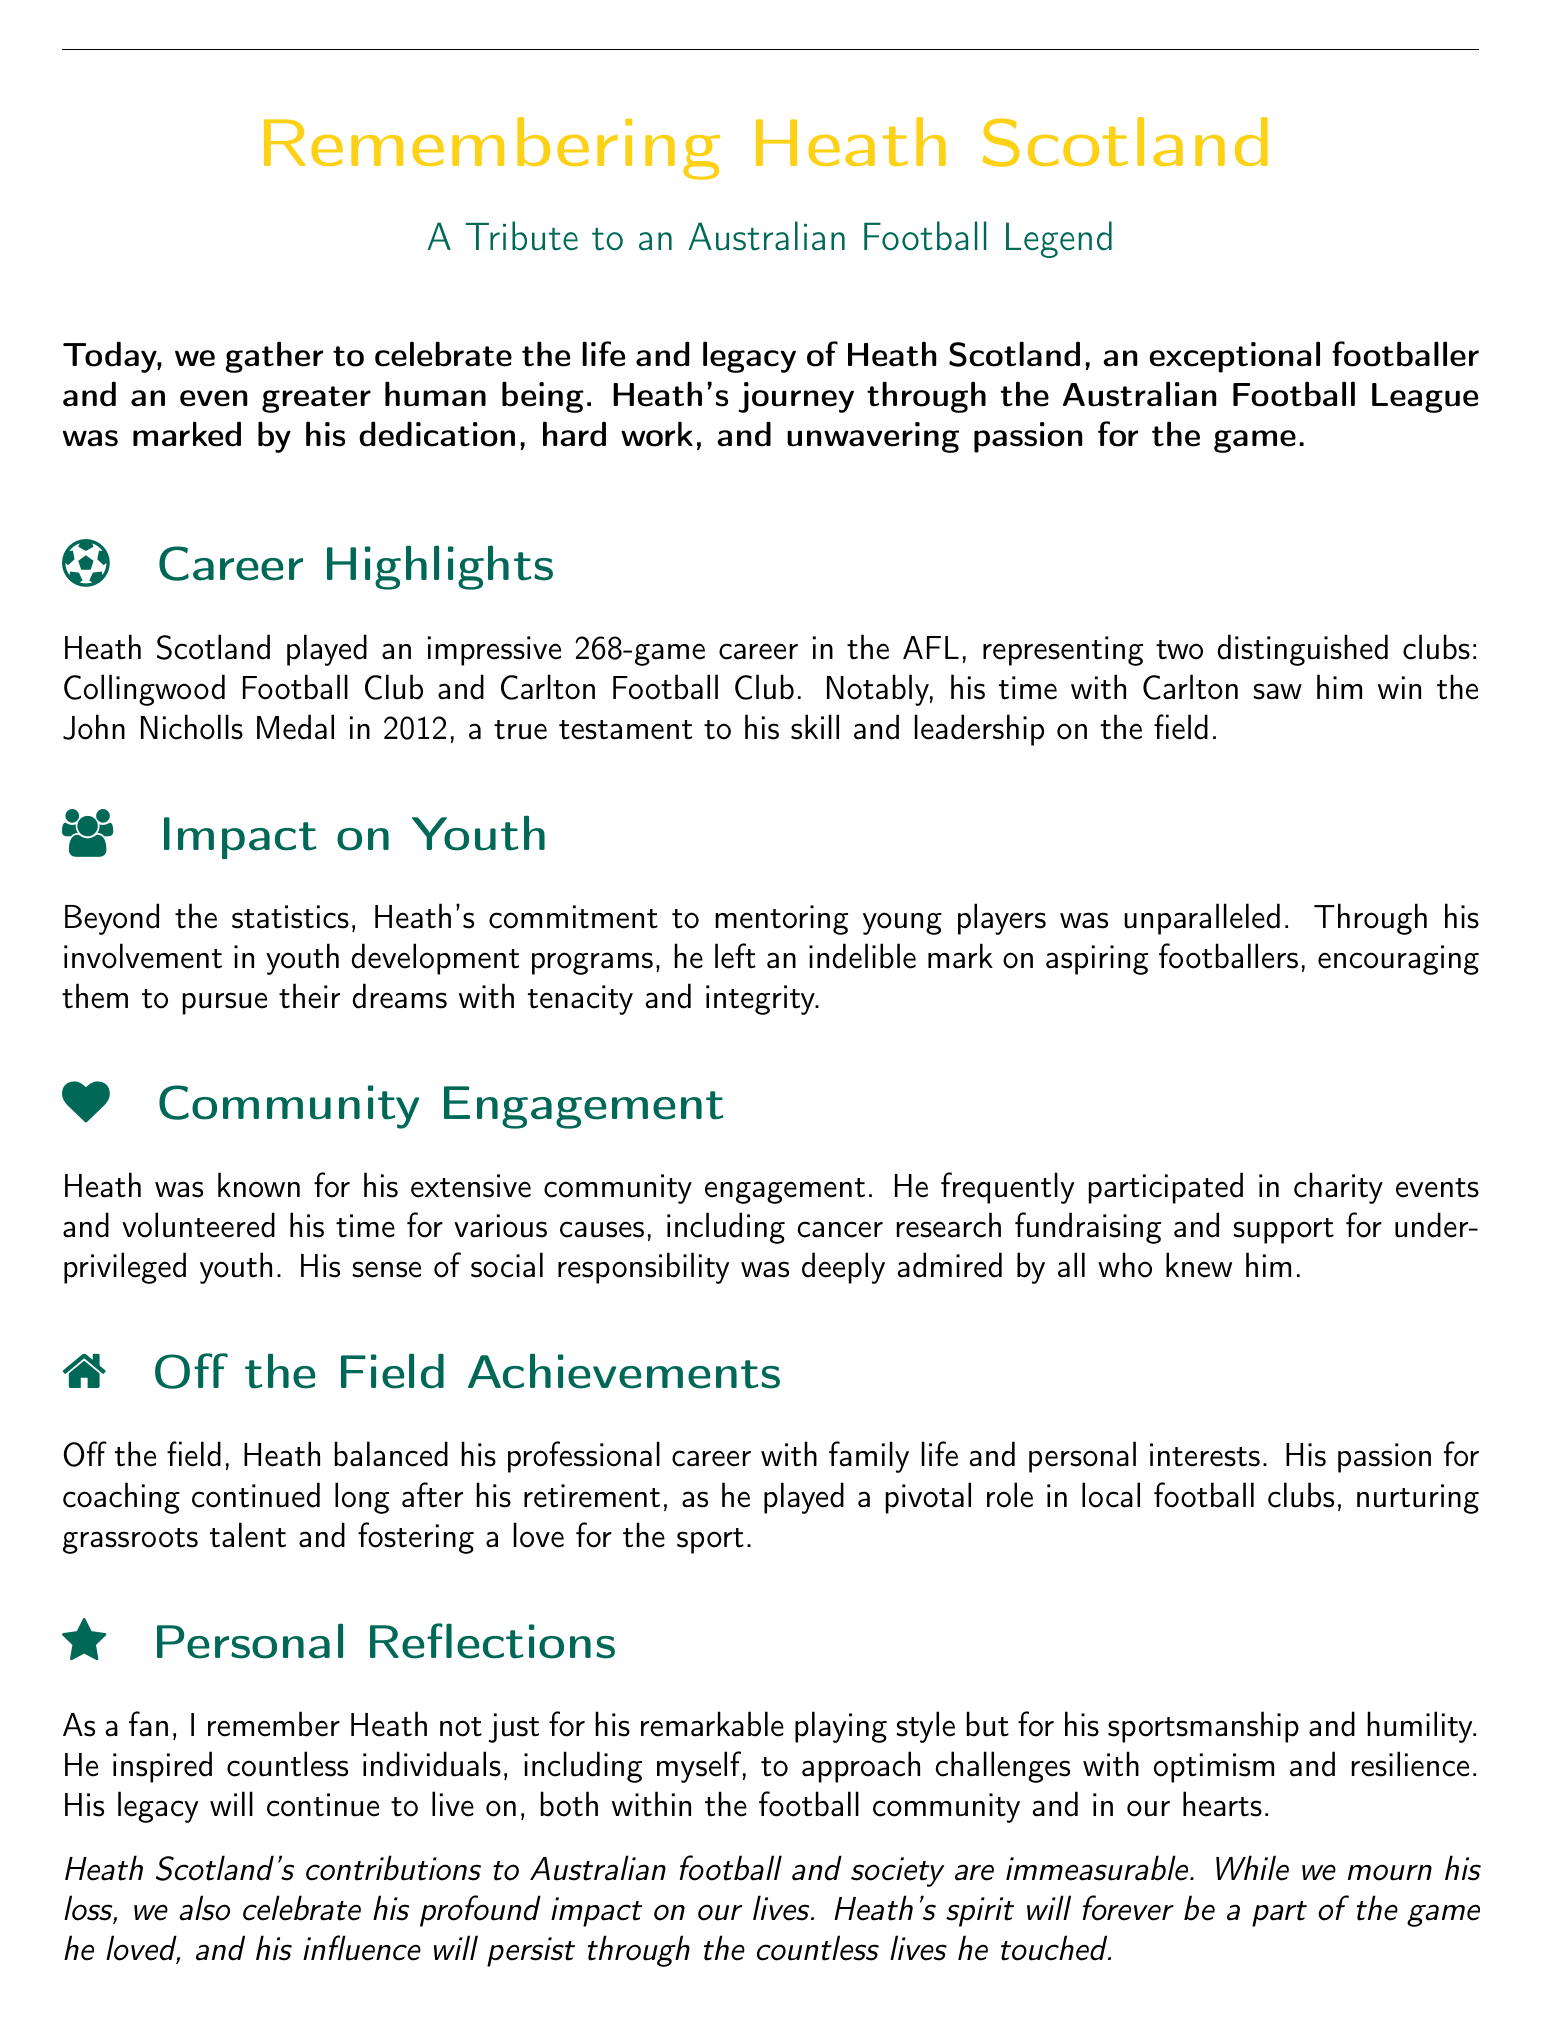What clubs did Heath Scotland represent? The document mentions that Heath Scotland played for two clubs: Collingwood Football Club and Carlton Football Club.
Answer: Collingwood Football Club and Carlton Football Club What award did Heath Scotland win in 2012? The document indicates that Heath won the John Nicholls Medal in 2012, highlighting his achievements during that year.
Answer: John Nicholls Medal How many games did Heath Scotland play in his AFL career? The document specifies that Heath had an impressive 268-game career in the AFL.
Answer: 268 What type of programs was Heath Scotland involved with? The document states that Heath was committed to mentoring young players through involvement in youth development programs.
Answer: Youth development programs What was one of Heath's contributions to the community? The document lists several activities, including participation in charity events and volunteer work for various causes.
Answer: Charity events In which sport did Heath Scotland primarily engage after retirement? The document mentions that Heath had a passion for coaching and played a role in local football clubs post-retirement.
Answer: Football What personal qualities did Heath Scotland demonstrate according to the reflections? The document highlights Heath's sportsmanship and humility as key personal reflections.
Answer: Sportsmanship and humility What is the overall theme of this document? The document serves as a eulogy, celebrating Heath Scotland's life, legacy, and contributions to Australian football and society.
Answer: Eulogy 